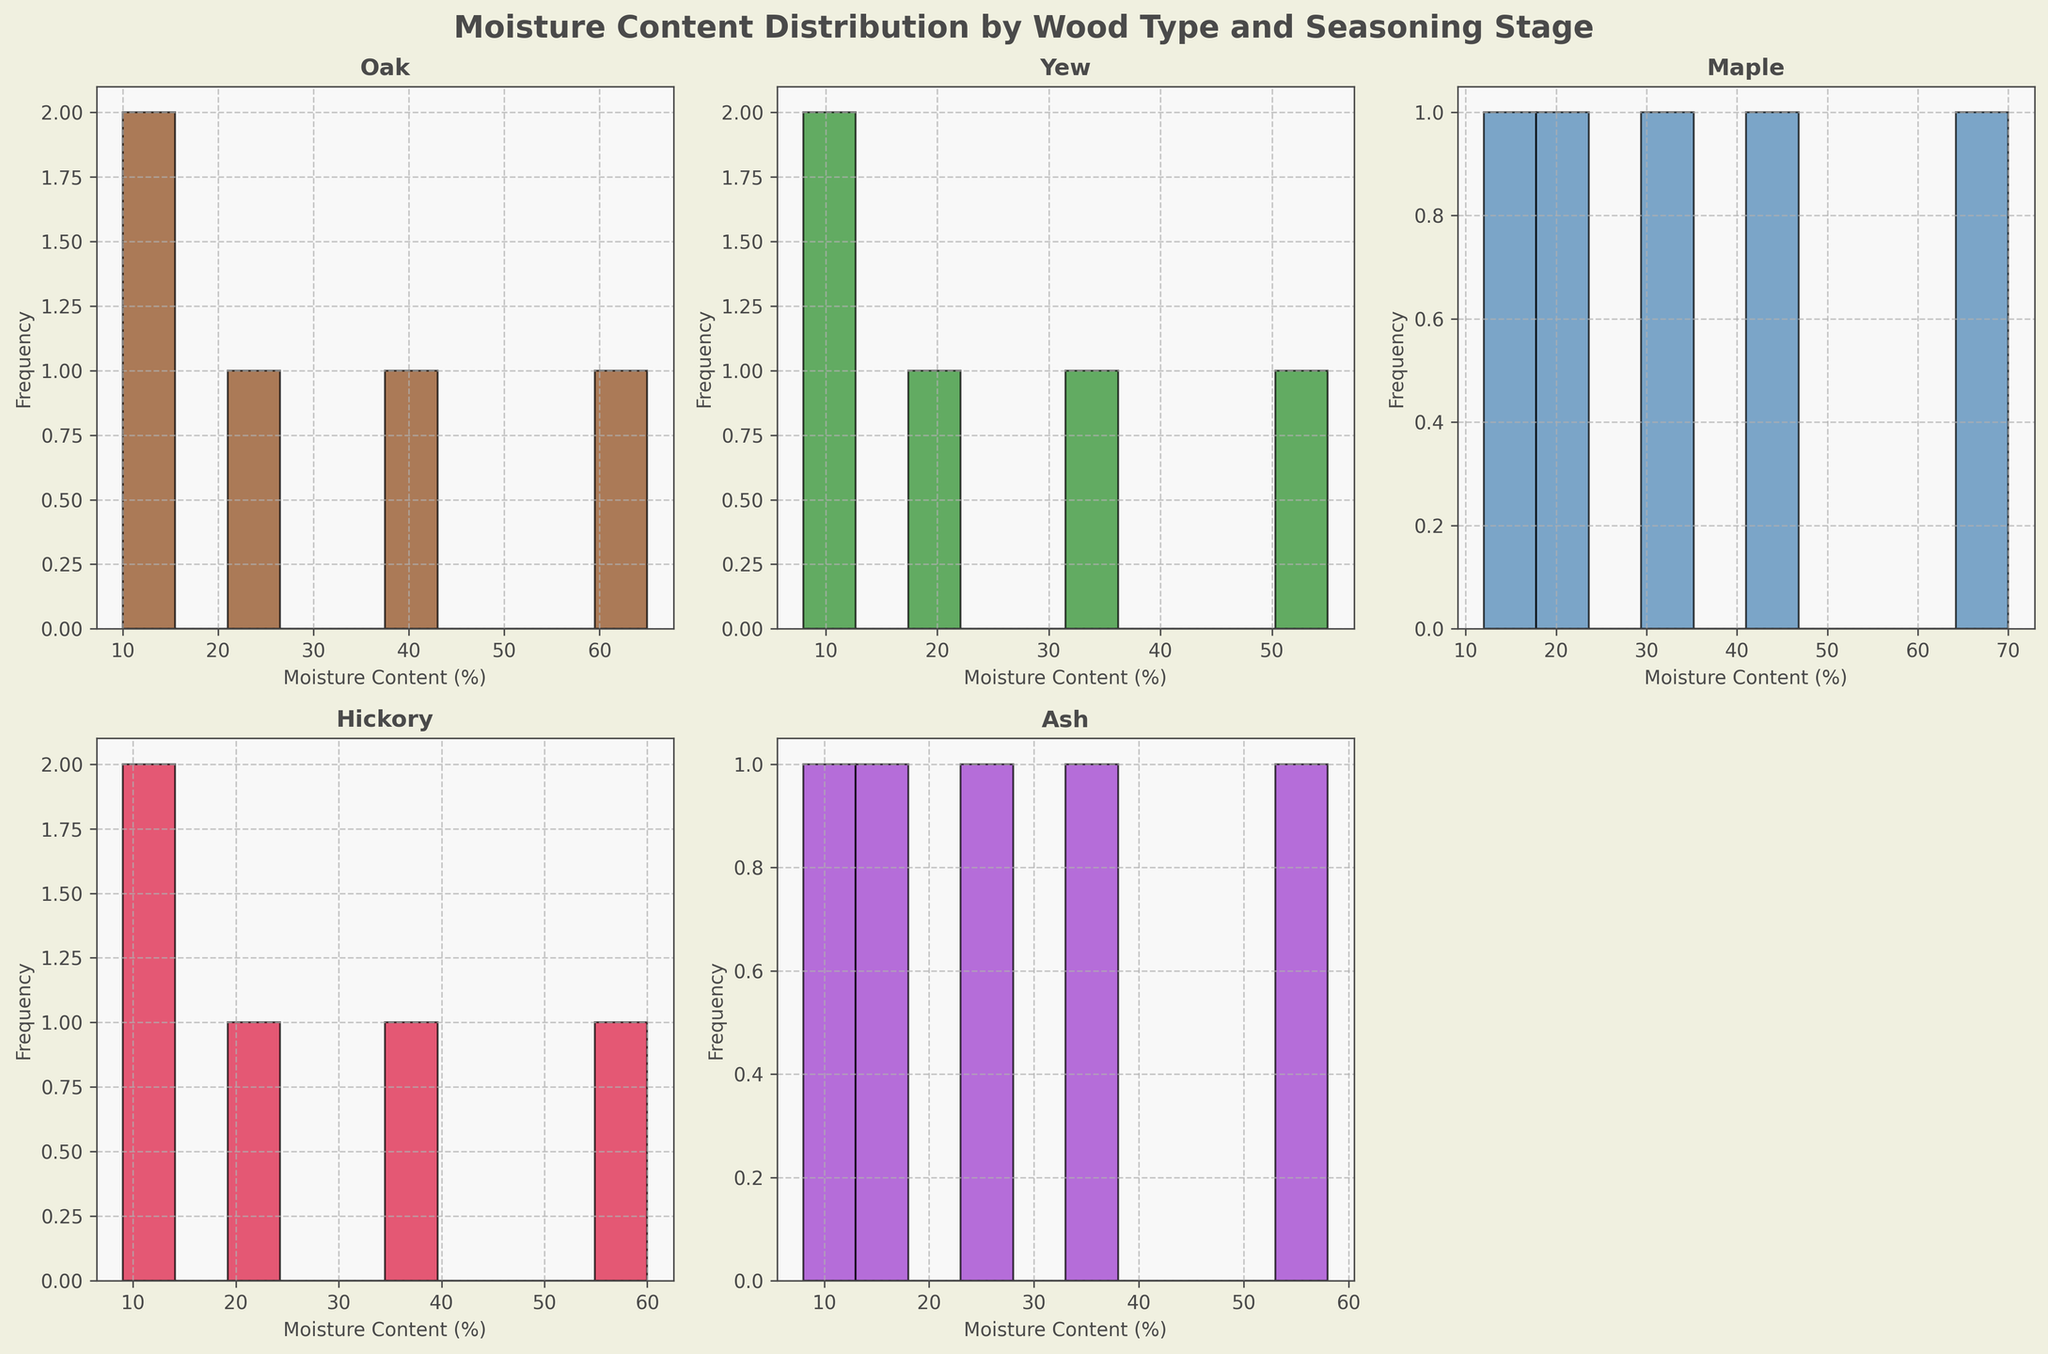What is the title of the figure? The title is displayed at the top center of the figure. It reads, "Moisture Content Distribution by Wood Type and Seasoning Stage."
Answer: Moisture Content Distribution by Wood Type and Seasoning Stage How many subplots are present in the figure? There are 2 rows and 3 columns of subplots, but one subplot is intentionally removed, leaving a total of 5 active subplots.
Answer: 5 Which wood type has the lowest moisture content after 2 years of seasoning? Refer to the subplot for each wood type and look at the moisture content distribution. Yew and Ash both have a 2-year moisture content of 8%, and these are the lowest recorded values.
Answer: Yew and Ash How does the distribution in moisture content for freshly cut Maple compare to freshly cut Oak? Inspect the histograms for both Maple and Oak at the "Freshly Cut" stage. Maple's histogram should show a moisture content around 70%, while Oak's histogram should show around 65%.
Answer: Maple has higher moisture content when freshly cut Which wood type shows the most dramatic reduction in moisture content in the first 3 months? Compare the distribution of moisture content from "Freshly Cut" to "3 Months" stages for all wood types. Maple decreases from 70% to 45%, the highest numerical drop of 25%.
Answer: Maple What is the color of the Oak histogram? Identify Oak's subplot and note the color used. The color is a shade of brown.
Answer: Brown Which seasoning stage has the highest frequency of moisture content in the Ash wood type? Inspect Ash's subplot and identify the highest bar. The seasoning stage with the highest frequency is "3 Months," where the bar represents a moisture content around 36%.
Answer: 3 Months Do any two wood types share the same moisture content after 1 year? If yes, which ones? Compare the "1 Year" stage moisture contents across all subplots. Both Yew and Ash have a 1-year moisture content value of 12%.
Answer: Yew and Ash What patterns can you observe about the change in moisture content over time for Hickory? Look at Hickory's subplot and note the decrease in moisture content from "Freshly Cut" to "2 Years." It drops from 60% to 9%, showing a consistent reduction over each stage.
Answer: Decreasing consistently over time Which wood type has the smallest change in moisture content from "6 Months" to "1 Year"? Compare the moisture content values for all wood types between "6 Months" and "1 Year." Oak decreases from 25% to 15%, a drop of 10%, the smallest change among all.
Answer: Oak 